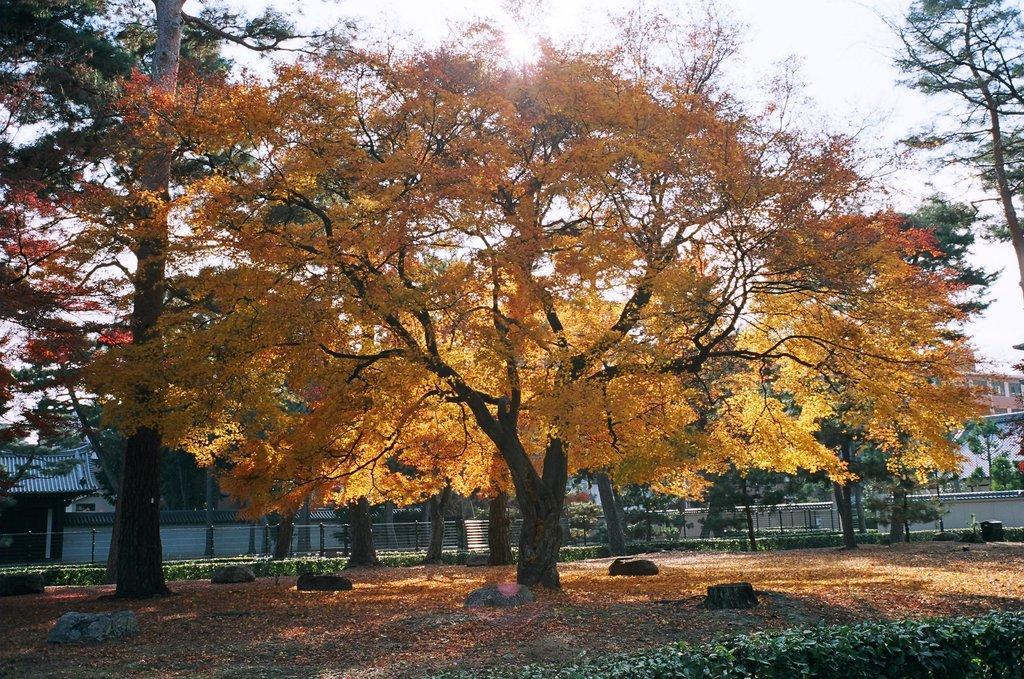Please provide a concise description of this image. In this picture I can see so many tree, behind we can see some houses and buildings. 